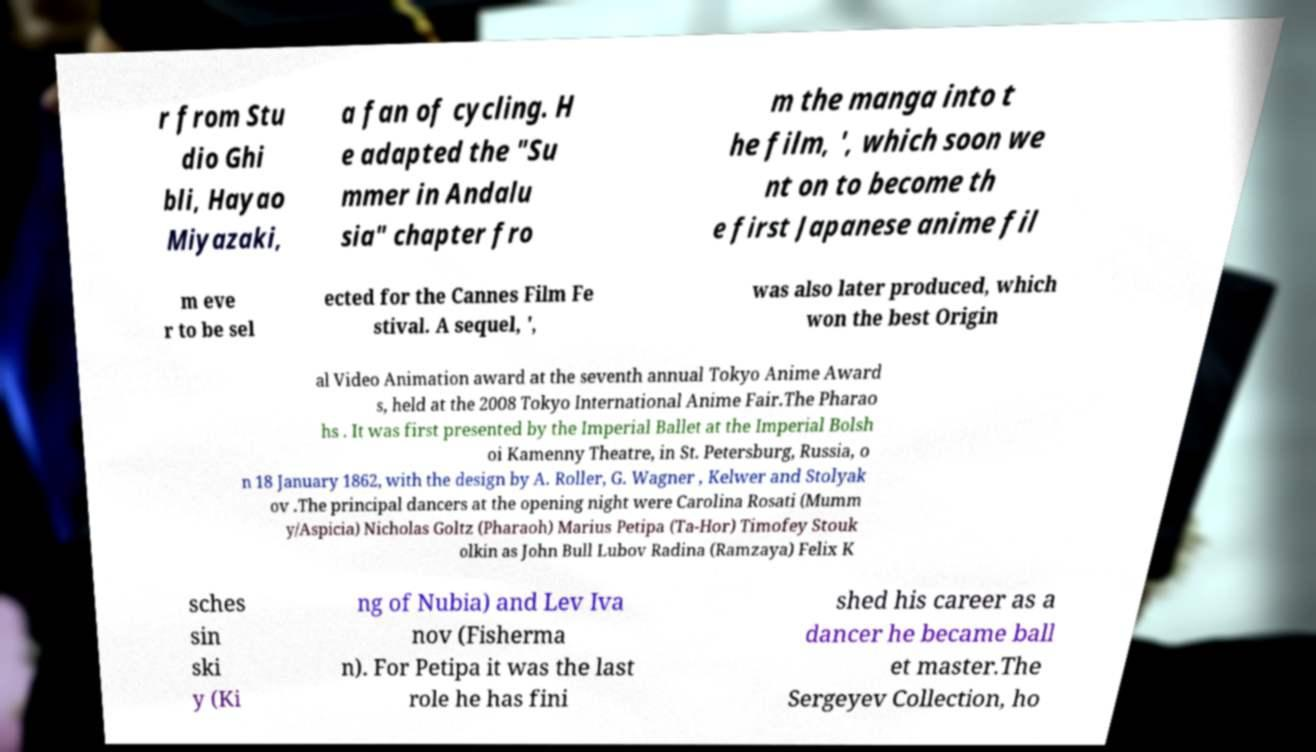Could you extract and type out the text from this image? r from Stu dio Ghi bli, Hayao Miyazaki, a fan of cycling. H e adapted the "Su mmer in Andalu sia" chapter fro m the manga into t he film, ', which soon we nt on to become th e first Japanese anime fil m eve r to be sel ected for the Cannes Film Fe stival. A sequel, ', was also later produced, which won the best Origin al Video Animation award at the seventh annual Tokyo Anime Award s, held at the 2008 Tokyo International Anime Fair.The Pharao hs . It was first presented by the Imperial Ballet at the Imperial Bolsh oi Kamenny Theatre, in St. Petersburg, Russia, o n 18 January 1862, with the design by A. Roller, G. Wagner , Kelwer and Stolyak ov .The principal dancers at the opening night were Carolina Rosati (Mumm y/Aspicia) Nicholas Goltz (Pharaoh) Marius Petipa (Ta-Hor) Timofey Stouk olkin as John Bull Lubov Radina (Ramzaya) Felix K sches sin ski y (Ki ng of Nubia) and Lev Iva nov (Fisherma n). For Petipa it was the last role he has fini shed his career as a dancer he became ball et master.The Sergeyev Collection, ho 